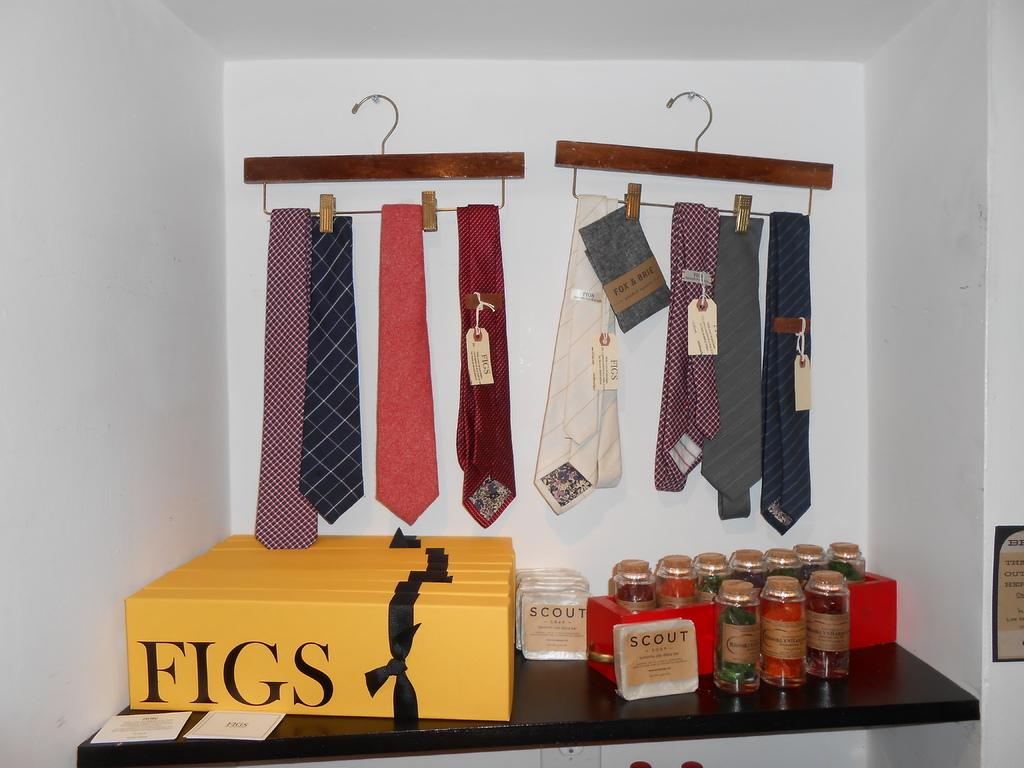<image>
Offer a succinct explanation of the picture presented. Several ties are hanging up in the background and there are yellow boxes out that say "FIGS". 